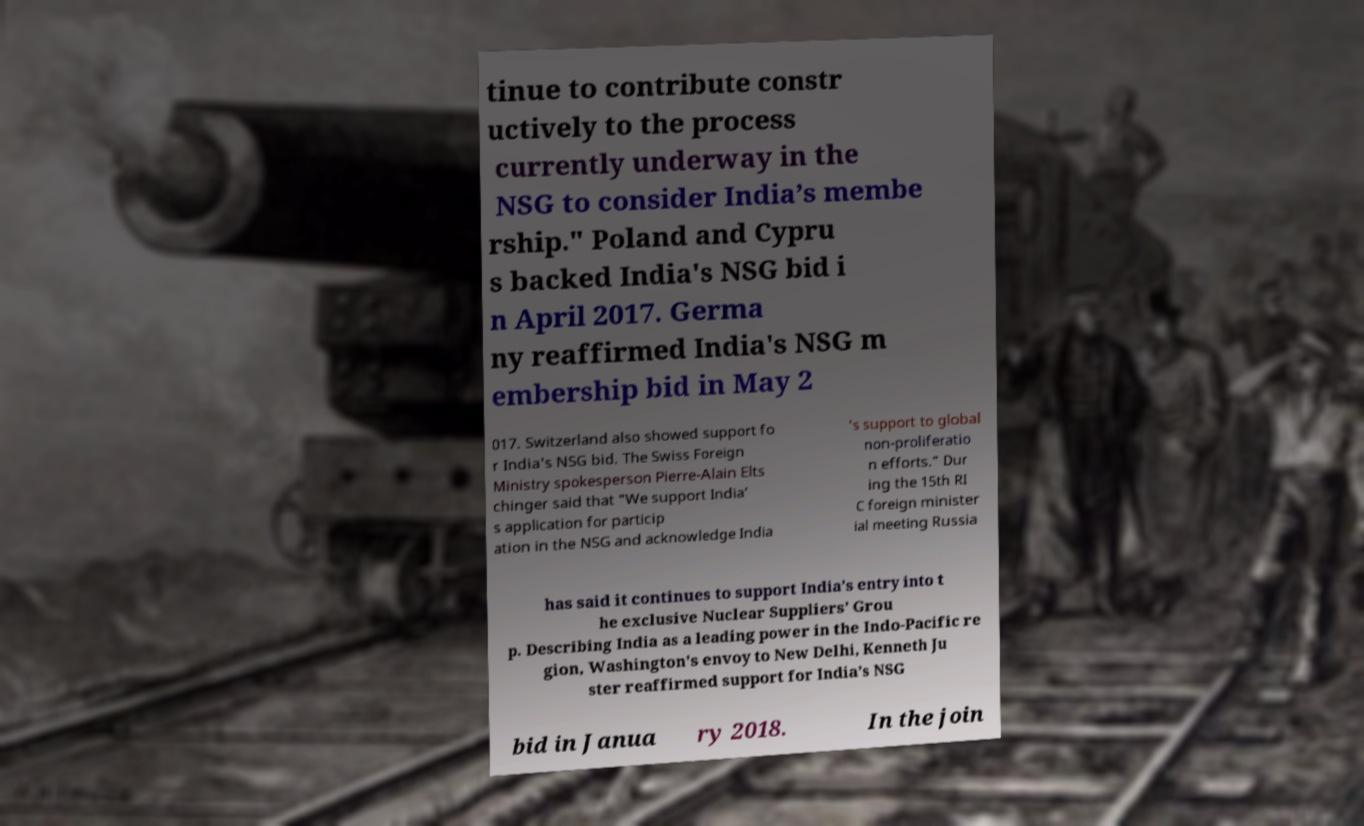Please read and relay the text visible in this image. What does it say? tinue to contribute constr uctively to the process currently underway in the NSG to consider India’s membe rship." Poland and Cypru s backed India's NSG bid i n April 2017. Germa ny reaffirmed India's NSG m embership bid in May 2 017. Switzerland also showed support fo r India's NSG bid. The Swiss Foreign Ministry spokesperson Pierre-Alain Elts chinger said that “We support India’ s application for particip ation in the NSG and acknowledge India ’s support to global non-proliferatio n efforts.” Dur ing the 15th RI C foreign minister ial meeting Russia has said it continues to support India’s entry into t he exclusive Nuclear Suppliers’ Grou p. Describing India as a leading power in the Indo-Pacific re gion, Washington's envoy to New Delhi, Kenneth Ju ster reaffirmed support for India’s NSG bid in Janua ry 2018. In the join 